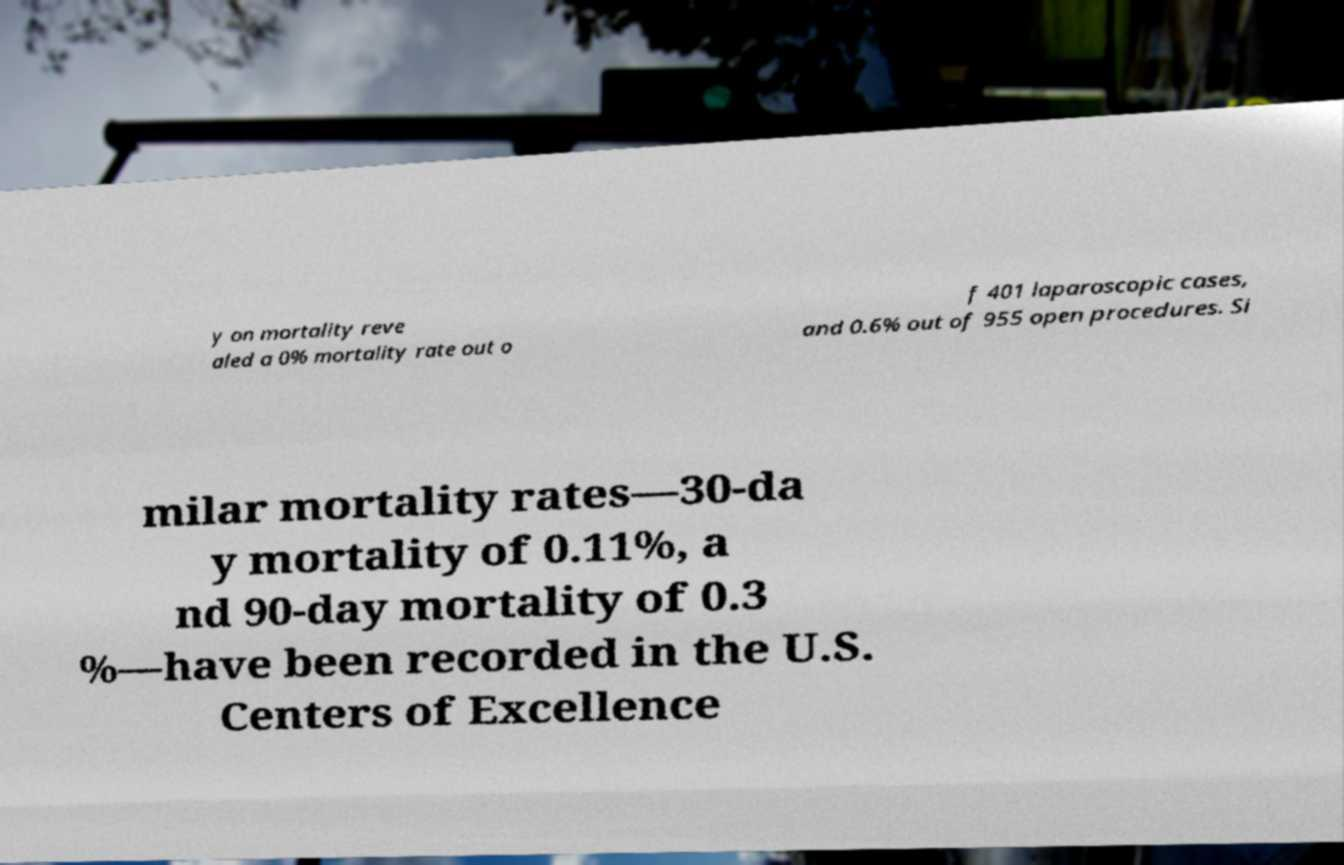For documentation purposes, I need the text within this image transcribed. Could you provide that? y on mortality reve aled a 0% mortality rate out o f 401 laparoscopic cases, and 0.6% out of 955 open procedures. Si milar mortality rates—30-da y mortality of 0.11%, a nd 90-day mortality of 0.3 %—have been recorded in the U.S. Centers of Excellence 